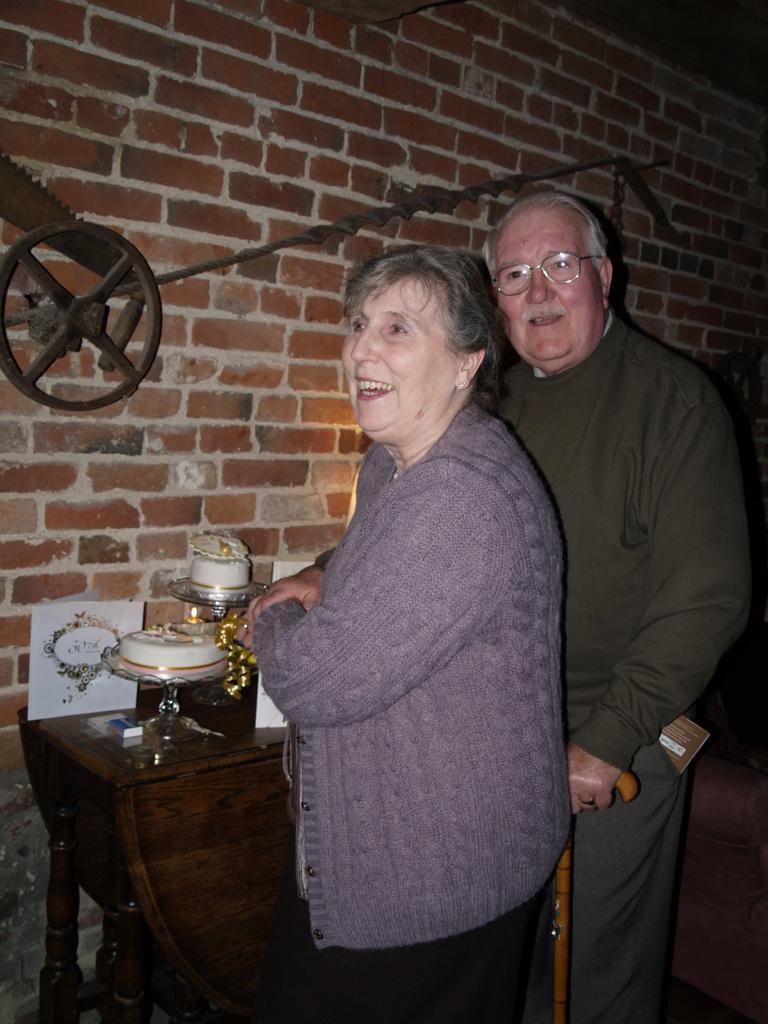How would you summarize this image in a sentence or two? Here we can see an old man and an old woman standing in front of a table with something on it and the old man is having a stick in his hand 